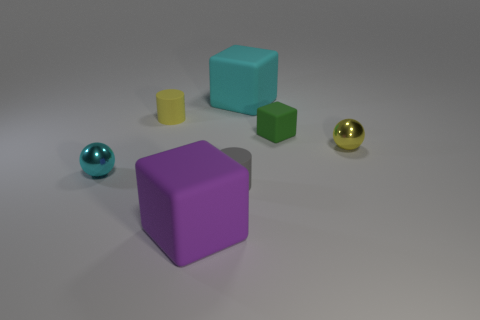Add 2 tiny green objects. How many objects exist? 9 Subtract all blocks. How many objects are left? 4 Subtract 2 cylinders. How many cylinders are left? 0 Subtract all purple spheres. Subtract all purple cubes. How many spheres are left? 2 Subtract all green balls. How many purple cylinders are left? 0 Subtract all tiny yellow spheres. Subtract all yellow balls. How many objects are left? 5 Add 4 cyan shiny balls. How many cyan shiny balls are left? 5 Add 1 green matte cubes. How many green matte cubes exist? 2 Subtract all purple cubes. How many cubes are left? 2 Subtract all big rubber cubes. How many cubes are left? 1 